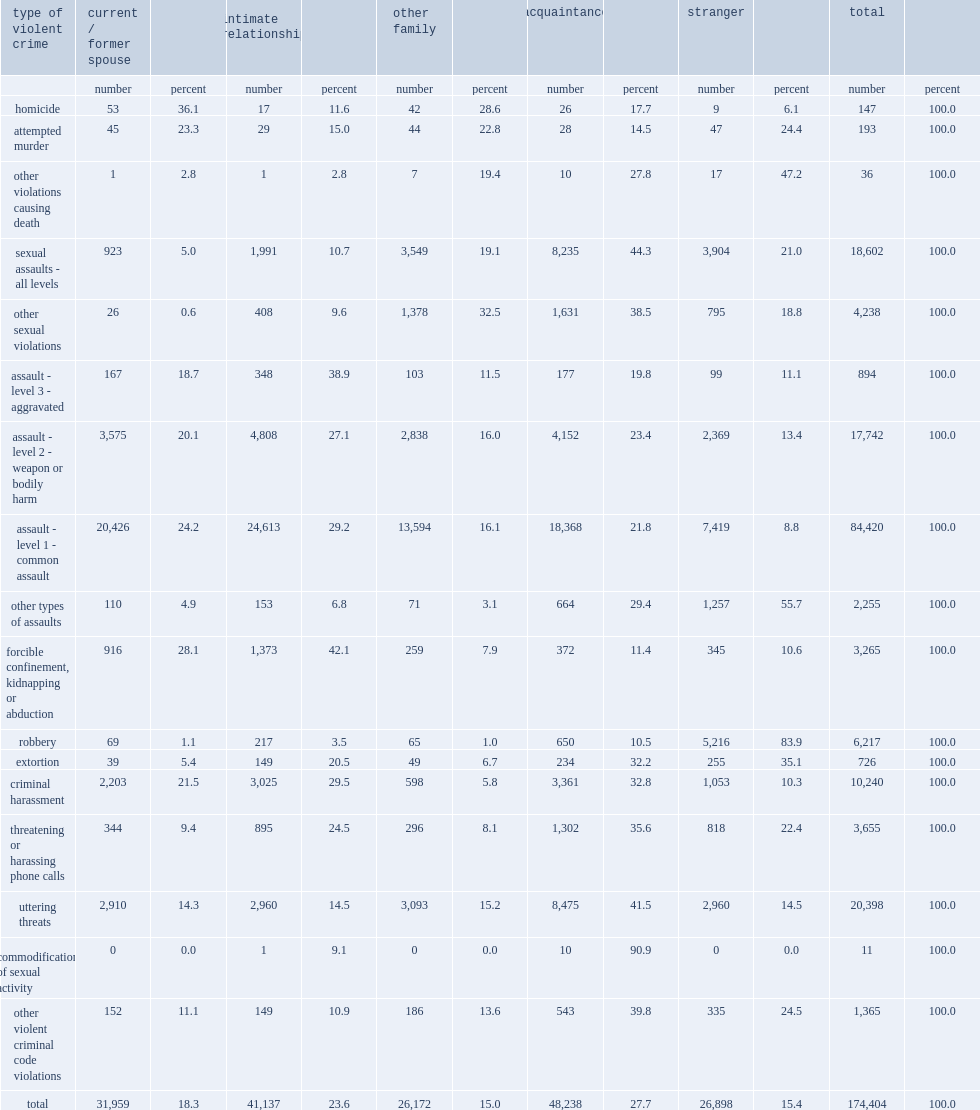What is the percentage of violent incidents involving female victims committed by spouses (current or former) and other intimate partners? 41.9. What is the percentage of violent incidents committed by other family members and acquaintances? 42.7. 